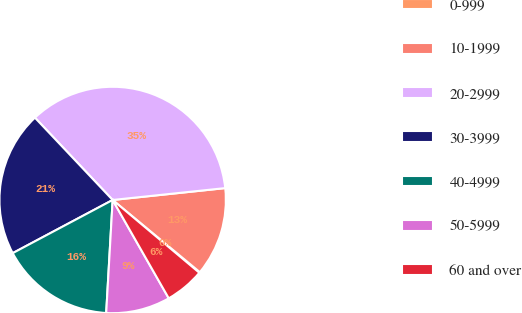<chart> <loc_0><loc_0><loc_500><loc_500><pie_chart><fcel>0-999<fcel>10-1999<fcel>20-2999<fcel>30-3999<fcel>40-4999<fcel>50-5999<fcel>60 and over<nl><fcel>0.11%<fcel>12.68%<fcel>35.37%<fcel>20.73%<fcel>16.31%<fcel>9.16%<fcel>5.63%<nl></chart> 